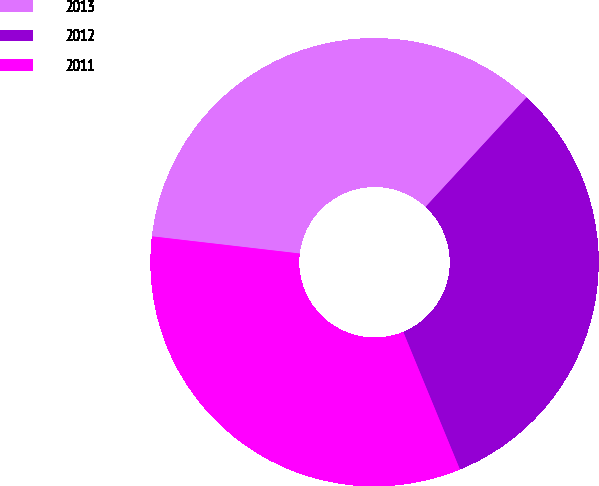Convert chart. <chart><loc_0><loc_0><loc_500><loc_500><pie_chart><fcel>2013<fcel>2012<fcel>2011<nl><fcel>35.02%<fcel>31.92%<fcel>33.06%<nl></chart> 